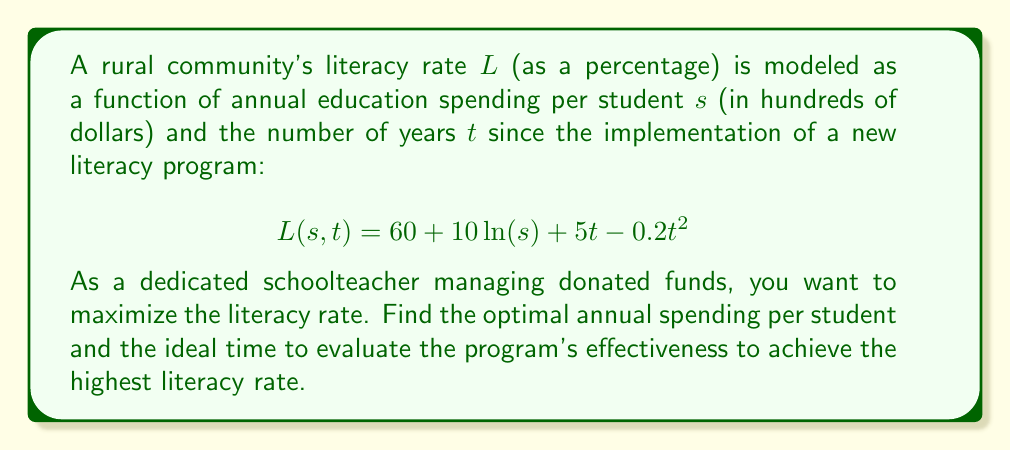Give your solution to this math problem. To find the maximum literacy rate, we need to find the critical points of the function $L(s,t)$ by taking partial derivatives and setting them equal to zero:

1. Partial derivative with respect to $s$:
   $$\frac{\partial L}{\partial s} = \frac{10}{s}$$

2. Partial derivative with respect to $t$:
   $$\frac{\partial L}{\partial t} = 5 - 0.4t$$

3. Set both partial derivatives to zero and solve:
   $$\frac{\partial L}{\partial s} = \frac{10}{s} = 0$$
   This equation has no solution for finite $s$, indicating that increasing $s$ always improves the literacy rate.

   $$\frac{\partial L}{\partial t} = 5 - 0.4t = 0$$
   $$0.4t = 5$$
   $$t = 12.5\text{ years}$$

4. To confirm this is a maximum, we calculate the second partial derivatives:
   $$\frac{\partial^2 L}{\partial s^2} = -\frac{10}{s^2} < 0 \text{ for all } s > 0$$
   $$\frac{\partial^2 L}{\partial t^2} = -0.4 < 0$$

   The negative second derivatives confirm a local maximum with respect to $t$.

5. Since there's no finite optimal $s$, we should allocate as much funding as possible. Let's assume the maximum possible annual spending per student is $\$2000$ (i.e., $s = 20$).

6. Substituting these values into the original function:
   $$L(20, 12.5) = 60 + 10\ln(20) + 5(12.5) - 0.2(12.5)^2$$
   $$= 60 + 29.96 + 62.5 - 31.25 = 121.21$$

Therefore, the optimal strategy is to maximize annual spending per student (up to $\$2000$ in this case) and evaluate the program's effectiveness after 12.5 years to achieve the highest literacy rate of approximately 121.21%.
Answer: Maximize annual spending per student; evaluate after 12.5 years. 